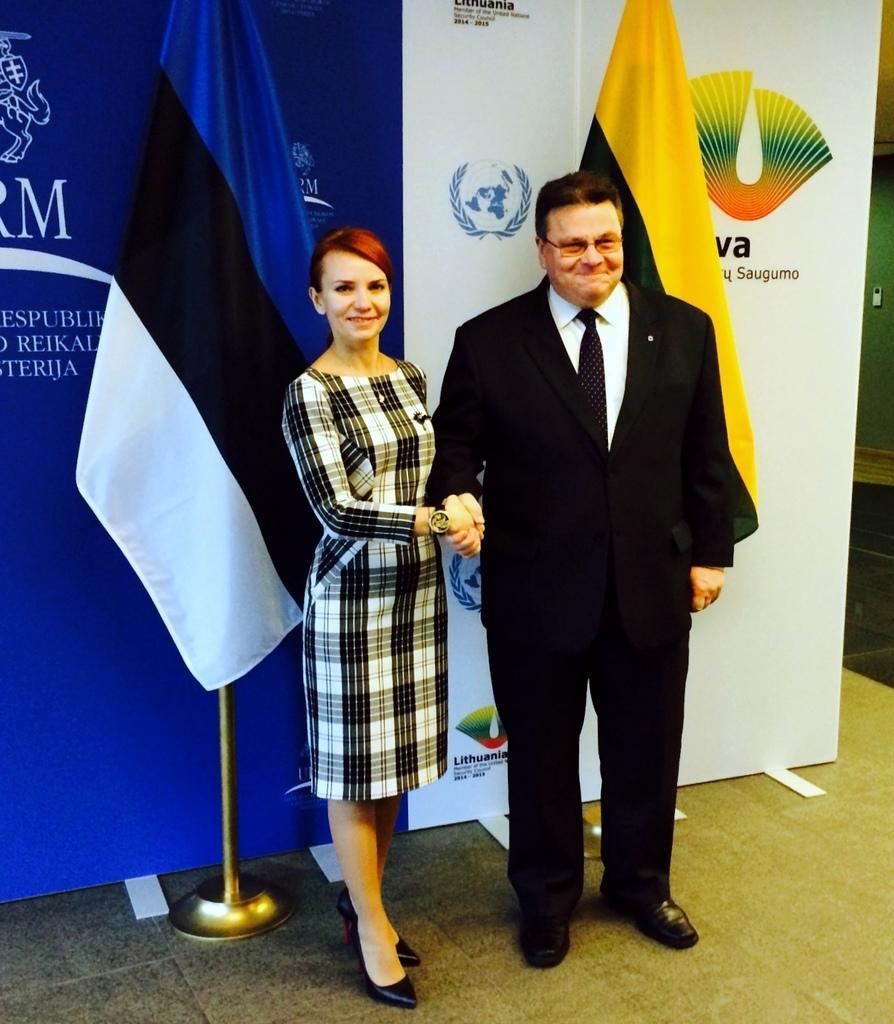Please provide a concise description of this image. In this image we can see two persons. In the background of the image there are flags, board and other objects. On the right side of the image there are some objects. At the bottom of the image there is a floor. 